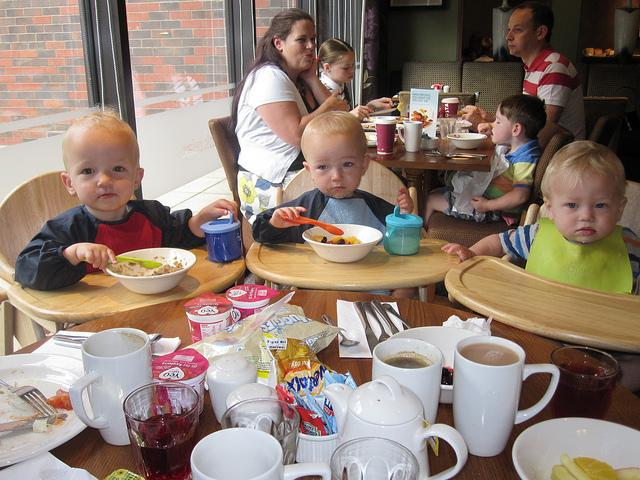Where are these 3 kids most likely from?

Choices:
A) same mother
B) different countries
C) nigeria
D) china same mother 